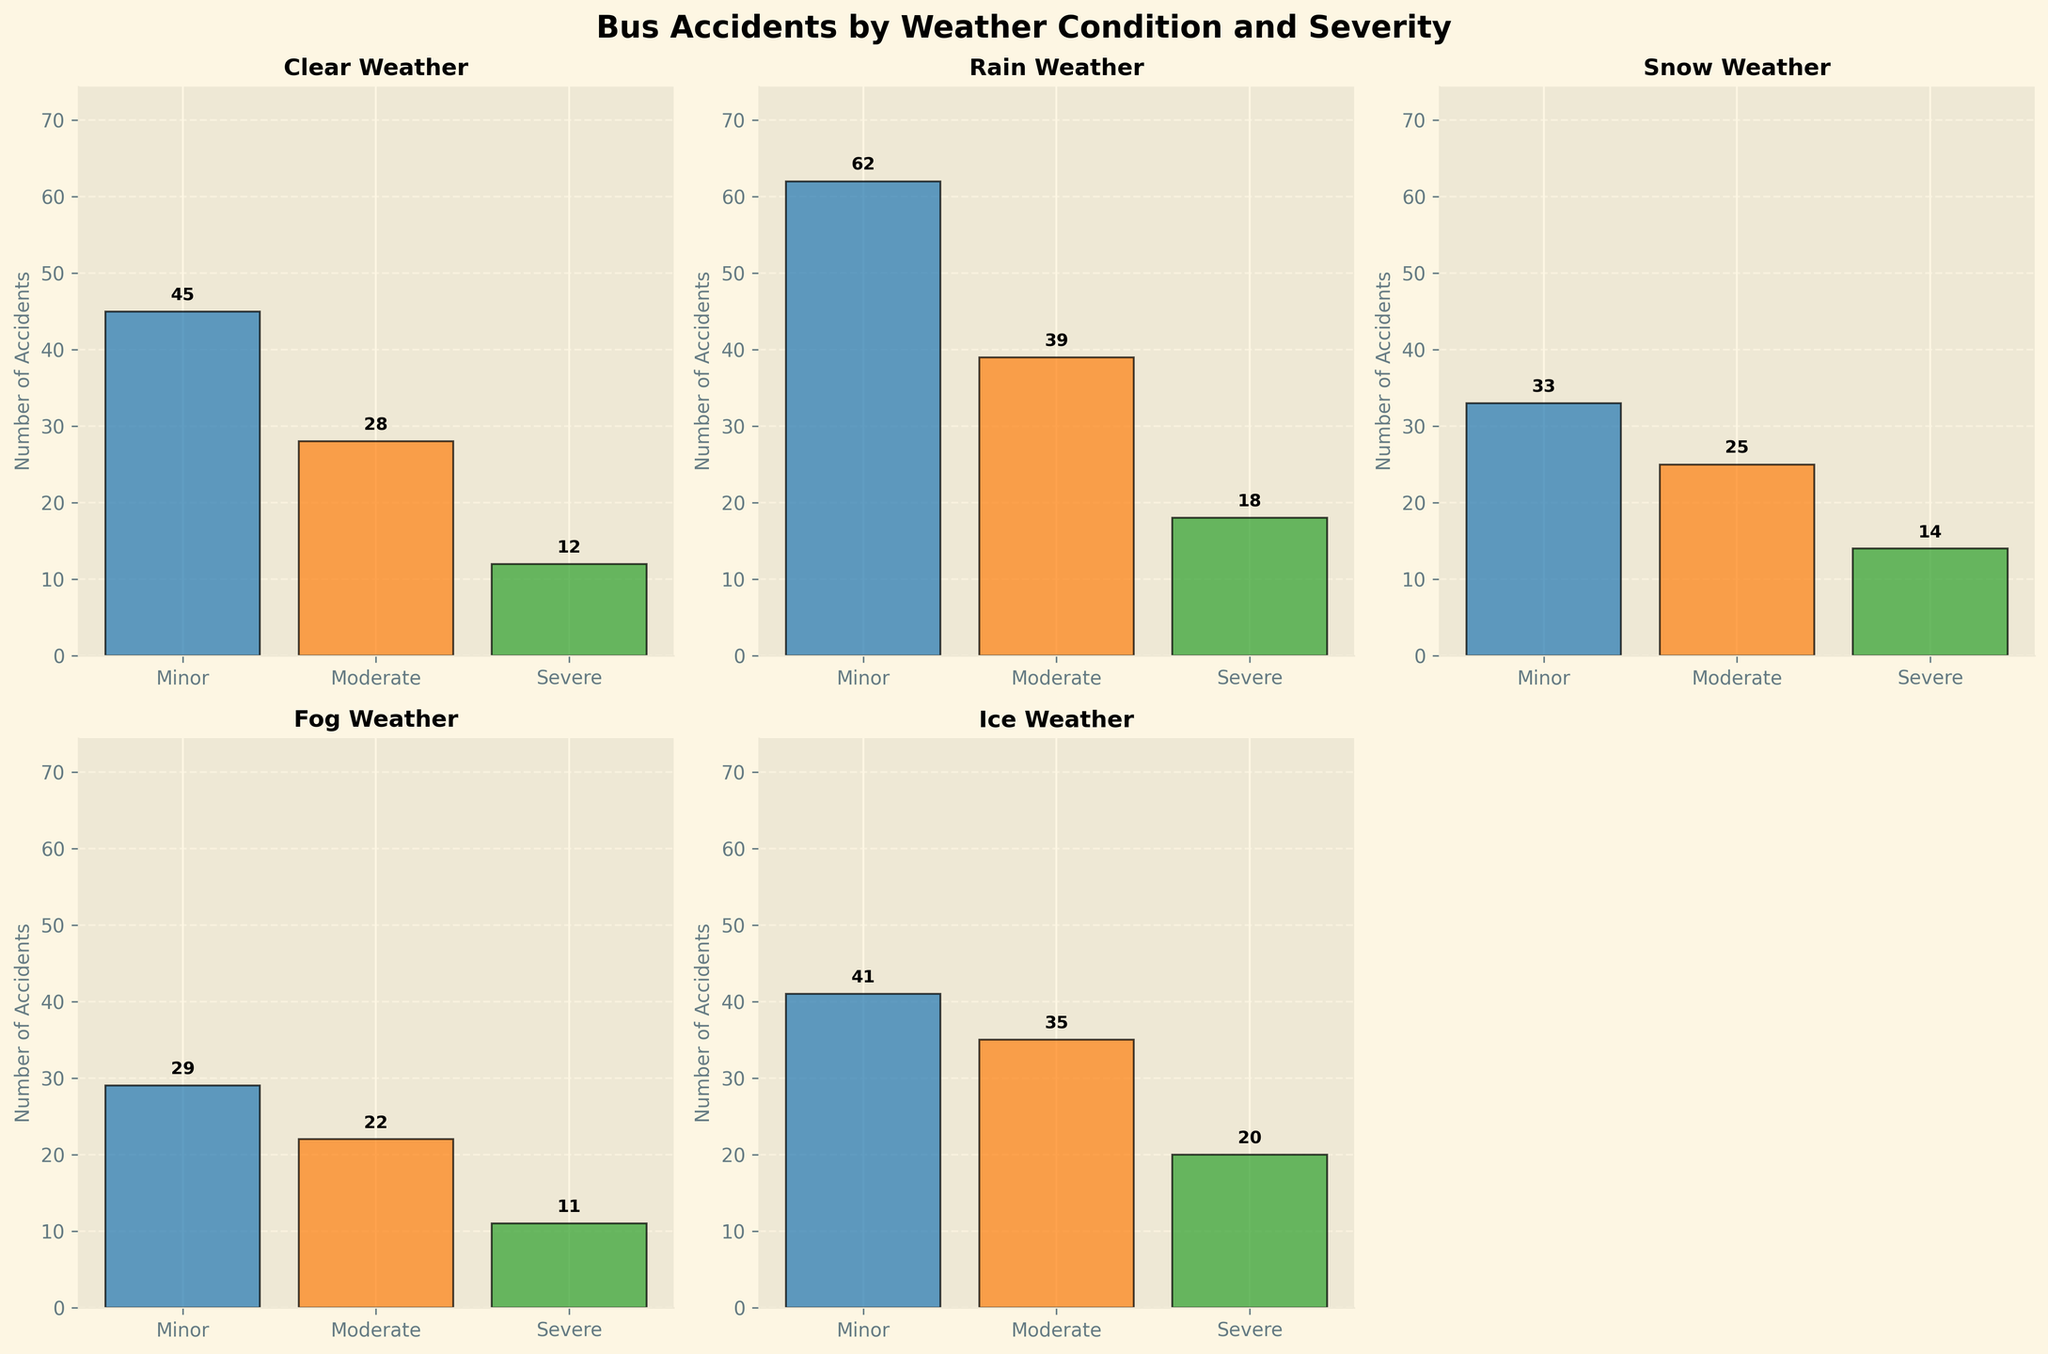How many severe accidents occurred in rainy weather? Look at the subplot titled "Rain Weather" and read the number above the "Severe" bar. The number above the bar for severe accidents is 18.
Answer: 18 What's the total number of accidents in snowy weather? Look at the subplot titled "Snow Weather" and sum the numbers above the bars for Minor, Moderate, and Severe accidents. The numbers are 33 (Minor), 25 (Moderate), and 14 (Severe), so 33 + 25 + 14 = 72.
Answer: 72 Which weather condition has the highest number of moderate accidents? Compare the numbers above the "Moderate" bars in each subplot. The highest number of moderate accidents is 39 in rainy weather.
Answer: Rain Are there more minor accidents in clear weather or icy weather? Compare the numbers above the "Minor" bars in the subplots for Clear and Ice. Clear weather has 45 minor accidents while Ice weather has 41. Hence, Clear weather has more minor accidents.
Answer: Clear What's the average number of accidents for foggy weather? Sum the numbers above the bars for Minor, Moderate, and Severe accidents in the Fog Weather subplot, then divide by 3. The numbers are 29 (Minor), 22 (Moderate), and 11 (Severe), so (29 + 22 + 11) / 3 ≈ 20.67.
Answer: 20.67 In which weather condition do severe accidents constitute the highest percentage of total accidents? For each weather condition, calculate the percentage of severe accidents out of total accidents. Clear: 12/85 ≈ 14.1%, Rain: 18/119 ≈ 15.1%, Snow: 14/72 ≈ 19.4%, Fog: 11/62 ≈ 17.7%, Ice: 20/96 ≈ 20.8%. Hence, the highest percentage is in Icy weather.
Answer: Ice What is the total number of accidents across all weather conditions? Sum the numbers above all the bars across all subplots. The total is 85 (Clear) + 119 (Rain) + 72 (Snow) + 62 (Fog) + 96 (Ice) = 434.
Answer: 434 